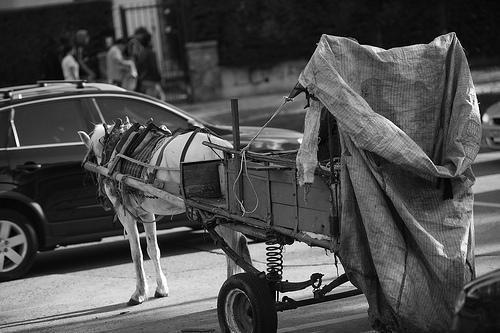How many horses are in the photo?
Give a very brief answer. 1. 